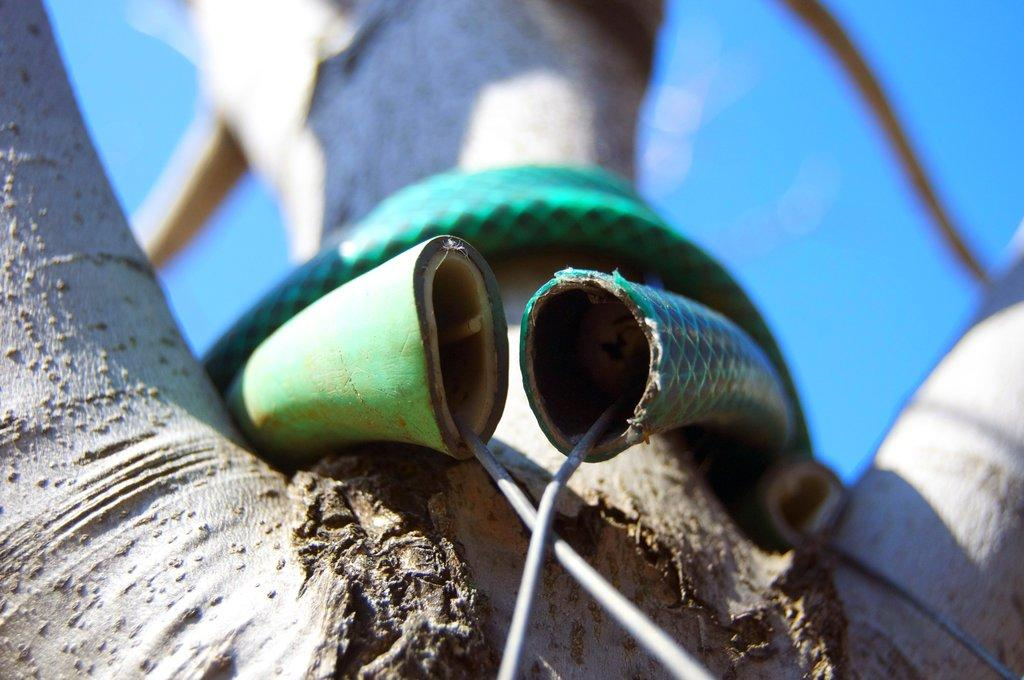What is the main object in the image? There is a tree in the image. Is there anything unusual about the tree? Yes, there is a pipe attached to the tree. What is inside the pipe? There are wires inside the pipe. What can be seen in the background of the image? The sky is visible in the background of the image. What type of worm can be seen crawling on the tree in the image? There are no worms present in the image; it only features a tree with a pipe and wires. How many daughters are visible in the image? There are no people, let alone daughters, present in the image. 